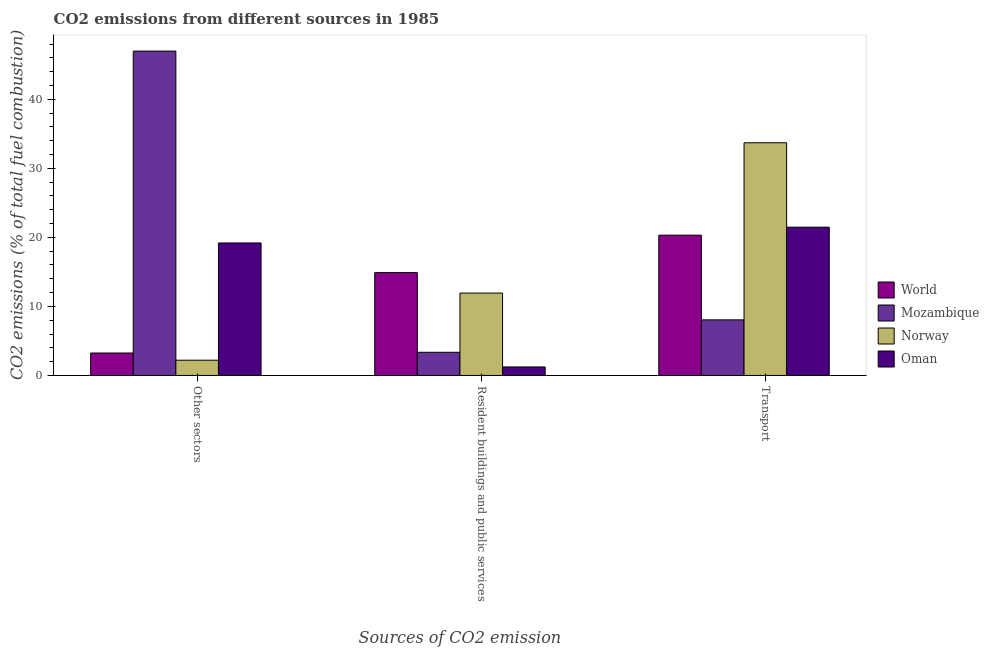How many bars are there on the 2nd tick from the right?
Ensure brevity in your answer.  4. What is the label of the 2nd group of bars from the left?
Make the answer very short. Resident buildings and public services. What is the percentage of co2 emissions from other sectors in Norway?
Make the answer very short. 2.21. Across all countries, what is the maximum percentage of co2 emissions from other sectors?
Your answer should be compact. 46.98. Across all countries, what is the minimum percentage of co2 emissions from transport?
Offer a terse response. 8.05. In which country was the percentage of co2 emissions from resident buildings and public services minimum?
Your answer should be very brief. Oman. What is the total percentage of co2 emissions from other sectors in the graph?
Your answer should be very brief. 71.63. What is the difference between the percentage of co2 emissions from other sectors in Mozambique and that in Oman?
Keep it short and to the point. 27.79. What is the difference between the percentage of co2 emissions from resident buildings and public services in Mozambique and the percentage of co2 emissions from transport in Oman?
Offer a terse response. -18.12. What is the average percentage of co2 emissions from transport per country?
Offer a very short reply. 20.89. What is the difference between the percentage of co2 emissions from other sectors and percentage of co2 emissions from transport in Mozambique?
Your answer should be very brief. 38.93. What is the ratio of the percentage of co2 emissions from other sectors in World to that in Mozambique?
Keep it short and to the point. 0.07. Is the percentage of co2 emissions from resident buildings and public services in World less than that in Mozambique?
Your response must be concise. No. What is the difference between the highest and the second highest percentage of co2 emissions from resident buildings and public services?
Ensure brevity in your answer.  2.96. What is the difference between the highest and the lowest percentage of co2 emissions from other sectors?
Provide a short and direct response. 44.77. In how many countries, is the percentage of co2 emissions from other sectors greater than the average percentage of co2 emissions from other sectors taken over all countries?
Offer a terse response. 2. Is the sum of the percentage of co2 emissions from other sectors in World and Mozambique greater than the maximum percentage of co2 emissions from transport across all countries?
Give a very brief answer. Yes. What does the 2nd bar from the left in Resident buildings and public services represents?
Make the answer very short. Mozambique. What does the 4th bar from the right in Other sectors represents?
Provide a short and direct response. World. Is it the case that in every country, the sum of the percentage of co2 emissions from other sectors and percentage of co2 emissions from resident buildings and public services is greater than the percentage of co2 emissions from transport?
Keep it short and to the point. No. How many bars are there?
Provide a succinct answer. 12. Are all the bars in the graph horizontal?
Offer a terse response. No. Does the graph contain grids?
Keep it short and to the point. No. Where does the legend appear in the graph?
Provide a succinct answer. Center right. How are the legend labels stacked?
Give a very brief answer. Vertical. What is the title of the graph?
Make the answer very short. CO2 emissions from different sources in 1985. Does "Upper middle income" appear as one of the legend labels in the graph?
Give a very brief answer. No. What is the label or title of the X-axis?
Provide a short and direct response. Sources of CO2 emission. What is the label or title of the Y-axis?
Your answer should be compact. CO2 emissions (% of total fuel combustion). What is the CO2 emissions (% of total fuel combustion) of World in Other sectors?
Make the answer very short. 3.25. What is the CO2 emissions (% of total fuel combustion) in Mozambique in Other sectors?
Make the answer very short. 46.98. What is the CO2 emissions (% of total fuel combustion) in Norway in Other sectors?
Offer a very short reply. 2.21. What is the CO2 emissions (% of total fuel combustion) of Oman in Other sectors?
Provide a succinct answer. 19.19. What is the CO2 emissions (% of total fuel combustion) of World in Resident buildings and public services?
Keep it short and to the point. 14.89. What is the CO2 emissions (% of total fuel combustion) in Mozambique in Resident buildings and public services?
Provide a succinct answer. 3.36. What is the CO2 emissions (% of total fuel combustion) in Norway in Resident buildings and public services?
Your response must be concise. 11.93. What is the CO2 emissions (% of total fuel combustion) of Oman in Resident buildings and public services?
Your response must be concise. 1.23. What is the CO2 emissions (% of total fuel combustion) of World in Transport?
Provide a short and direct response. 20.32. What is the CO2 emissions (% of total fuel combustion) in Mozambique in Transport?
Give a very brief answer. 8.05. What is the CO2 emissions (% of total fuel combustion) of Norway in Transport?
Offer a very short reply. 33.7. What is the CO2 emissions (% of total fuel combustion) in Oman in Transport?
Your response must be concise. 21.48. Across all Sources of CO2 emission, what is the maximum CO2 emissions (% of total fuel combustion) of World?
Ensure brevity in your answer.  20.32. Across all Sources of CO2 emission, what is the maximum CO2 emissions (% of total fuel combustion) in Mozambique?
Your answer should be very brief. 46.98. Across all Sources of CO2 emission, what is the maximum CO2 emissions (% of total fuel combustion) of Norway?
Your response must be concise. 33.7. Across all Sources of CO2 emission, what is the maximum CO2 emissions (% of total fuel combustion) of Oman?
Make the answer very short. 21.48. Across all Sources of CO2 emission, what is the minimum CO2 emissions (% of total fuel combustion) in World?
Keep it short and to the point. 3.25. Across all Sources of CO2 emission, what is the minimum CO2 emissions (% of total fuel combustion) of Mozambique?
Provide a short and direct response. 3.36. Across all Sources of CO2 emission, what is the minimum CO2 emissions (% of total fuel combustion) in Norway?
Keep it short and to the point. 2.21. Across all Sources of CO2 emission, what is the minimum CO2 emissions (% of total fuel combustion) of Oman?
Your response must be concise. 1.23. What is the total CO2 emissions (% of total fuel combustion) of World in the graph?
Your answer should be very brief. 38.46. What is the total CO2 emissions (% of total fuel combustion) of Mozambique in the graph?
Your response must be concise. 58.39. What is the total CO2 emissions (% of total fuel combustion) in Norway in the graph?
Your answer should be very brief. 47.85. What is the total CO2 emissions (% of total fuel combustion) of Oman in the graph?
Your answer should be very brief. 41.9. What is the difference between the CO2 emissions (% of total fuel combustion) in World in Other sectors and that in Resident buildings and public services?
Offer a very short reply. -11.64. What is the difference between the CO2 emissions (% of total fuel combustion) in Mozambique in Other sectors and that in Resident buildings and public services?
Keep it short and to the point. 43.62. What is the difference between the CO2 emissions (% of total fuel combustion) of Norway in Other sectors and that in Resident buildings and public services?
Offer a terse response. -9.72. What is the difference between the CO2 emissions (% of total fuel combustion) in Oman in Other sectors and that in Resident buildings and public services?
Provide a succinct answer. 17.96. What is the difference between the CO2 emissions (% of total fuel combustion) in World in Other sectors and that in Transport?
Your response must be concise. -17.07. What is the difference between the CO2 emissions (% of total fuel combustion) of Mozambique in Other sectors and that in Transport?
Offer a very short reply. 38.93. What is the difference between the CO2 emissions (% of total fuel combustion) in Norway in Other sectors and that in Transport?
Offer a very short reply. -31.49. What is the difference between the CO2 emissions (% of total fuel combustion) of Oman in Other sectors and that in Transport?
Your answer should be very brief. -2.29. What is the difference between the CO2 emissions (% of total fuel combustion) of World in Resident buildings and public services and that in Transport?
Offer a very short reply. -5.42. What is the difference between the CO2 emissions (% of total fuel combustion) of Mozambique in Resident buildings and public services and that in Transport?
Offer a terse response. -4.7. What is the difference between the CO2 emissions (% of total fuel combustion) in Norway in Resident buildings and public services and that in Transport?
Give a very brief answer. -21.77. What is the difference between the CO2 emissions (% of total fuel combustion) in Oman in Resident buildings and public services and that in Transport?
Provide a short and direct response. -20.25. What is the difference between the CO2 emissions (% of total fuel combustion) of World in Other sectors and the CO2 emissions (% of total fuel combustion) of Mozambique in Resident buildings and public services?
Ensure brevity in your answer.  -0.1. What is the difference between the CO2 emissions (% of total fuel combustion) of World in Other sectors and the CO2 emissions (% of total fuel combustion) of Norway in Resident buildings and public services?
Your answer should be compact. -8.68. What is the difference between the CO2 emissions (% of total fuel combustion) in World in Other sectors and the CO2 emissions (% of total fuel combustion) in Oman in Resident buildings and public services?
Your answer should be compact. 2.02. What is the difference between the CO2 emissions (% of total fuel combustion) in Mozambique in Other sectors and the CO2 emissions (% of total fuel combustion) in Norway in Resident buildings and public services?
Give a very brief answer. 35.05. What is the difference between the CO2 emissions (% of total fuel combustion) of Mozambique in Other sectors and the CO2 emissions (% of total fuel combustion) of Oman in Resident buildings and public services?
Offer a very short reply. 45.75. What is the difference between the CO2 emissions (% of total fuel combustion) in Norway in Other sectors and the CO2 emissions (% of total fuel combustion) in Oman in Resident buildings and public services?
Offer a very short reply. 0.98. What is the difference between the CO2 emissions (% of total fuel combustion) in World in Other sectors and the CO2 emissions (% of total fuel combustion) in Mozambique in Transport?
Ensure brevity in your answer.  -4.8. What is the difference between the CO2 emissions (% of total fuel combustion) in World in Other sectors and the CO2 emissions (% of total fuel combustion) in Norway in Transport?
Keep it short and to the point. -30.45. What is the difference between the CO2 emissions (% of total fuel combustion) in World in Other sectors and the CO2 emissions (% of total fuel combustion) in Oman in Transport?
Make the answer very short. -18.23. What is the difference between the CO2 emissions (% of total fuel combustion) in Mozambique in Other sectors and the CO2 emissions (% of total fuel combustion) in Norway in Transport?
Provide a succinct answer. 13.28. What is the difference between the CO2 emissions (% of total fuel combustion) of Mozambique in Other sectors and the CO2 emissions (% of total fuel combustion) of Oman in Transport?
Your response must be concise. 25.5. What is the difference between the CO2 emissions (% of total fuel combustion) in Norway in Other sectors and the CO2 emissions (% of total fuel combustion) in Oman in Transport?
Make the answer very short. -19.27. What is the difference between the CO2 emissions (% of total fuel combustion) in World in Resident buildings and public services and the CO2 emissions (% of total fuel combustion) in Mozambique in Transport?
Your answer should be very brief. 6.84. What is the difference between the CO2 emissions (% of total fuel combustion) in World in Resident buildings and public services and the CO2 emissions (% of total fuel combustion) in Norway in Transport?
Offer a terse response. -18.81. What is the difference between the CO2 emissions (% of total fuel combustion) of World in Resident buildings and public services and the CO2 emissions (% of total fuel combustion) of Oman in Transport?
Your response must be concise. -6.58. What is the difference between the CO2 emissions (% of total fuel combustion) in Mozambique in Resident buildings and public services and the CO2 emissions (% of total fuel combustion) in Norway in Transport?
Provide a succinct answer. -30.35. What is the difference between the CO2 emissions (% of total fuel combustion) of Mozambique in Resident buildings and public services and the CO2 emissions (% of total fuel combustion) of Oman in Transport?
Give a very brief answer. -18.12. What is the difference between the CO2 emissions (% of total fuel combustion) in Norway in Resident buildings and public services and the CO2 emissions (% of total fuel combustion) in Oman in Transport?
Make the answer very short. -9.55. What is the average CO2 emissions (% of total fuel combustion) of World per Sources of CO2 emission?
Provide a short and direct response. 12.82. What is the average CO2 emissions (% of total fuel combustion) in Mozambique per Sources of CO2 emission?
Ensure brevity in your answer.  19.46. What is the average CO2 emissions (% of total fuel combustion) in Norway per Sources of CO2 emission?
Your response must be concise. 15.95. What is the average CO2 emissions (% of total fuel combustion) of Oman per Sources of CO2 emission?
Provide a succinct answer. 13.97. What is the difference between the CO2 emissions (% of total fuel combustion) of World and CO2 emissions (% of total fuel combustion) of Mozambique in Other sectors?
Your answer should be very brief. -43.73. What is the difference between the CO2 emissions (% of total fuel combustion) of World and CO2 emissions (% of total fuel combustion) of Norway in Other sectors?
Ensure brevity in your answer.  1.04. What is the difference between the CO2 emissions (% of total fuel combustion) in World and CO2 emissions (% of total fuel combustion) in Oman in Other sectors?
Your answer should be compact. -15.94. What is the difference between the CO2 emissions (% of total fuel combustion) in Mozambique and CO2 emissions (% of total fuel combustion) in Norway in Other sectors?
Provide a short and direct response. 44.77. What is the difference between the CO2 emissions (% of total fuel combustion) in Mozambique and CO2 emissions (% of total fuel combustion) in Oman in Other sectors?
Offer a very short reply. 27.79. What is the difference between the CO2 emissions (% of total fuel combustion) in Norway and CO2 emissions (% of total fuel combustion) in Oman in Other sectors?
Your answer should be compact. -16.98. What is the difference between the CO2 emissions (% of total fuel combustion) in World and CO2 emissions (% of total fuel combustion) in Mozambique in Resident buildings and public services?
Your answer should be compact. 11.54. What is the difference between the CO2 emissions (% of total fuel combustion) of World and CO2 emissions (% of total fuel combustion) of Norway in Resident buildings and public services?
Offer a very short reply. 2.96. What is the difference between the CO2 emissions (% of total fuel combustion) in World and CO2 emissions (% of total fuel combustion) in Oman in Resident buildings and public services?
Provide a succinct answer. 13.66. What is the difference between the CO2 emissions (% of total fuel combustion) of Mozambique and CO2 emissions (% of total fuel combustion) of Norway in Resident buildings and public services?
Offer a very short reply. -8.58. What is the difference between the CO2 emissions (% of total fuel combustion) in Mozambique and CO2 emissions (% of total fuel combustion) in Oman in Resident buildings and public services?
Your answer should be compact. 2.12. What is the difference between the CO2 emissions (% of total fuel combustion) in Norway and CO2 emissions (% of total fuel combustion) in Oman in Resident buildings and public services?
Your answer should be very brief. 10.7. What is the difference between the CO2 emissions (% of total fuel combustion) of World and CO2 emissions (% of total fuel combustion) of Mozambique in Transport?
Provide a short and direct response. 12.26. What is the difference between the CO2 emissions (% of total fuel combustion) of World and CO2 emissions (% of total fuel combustion) of Norway in Transport?
Your response must be concise. -13.38. What is the difference between the CO2 emissions (% of total fuel combustion) of World and CO2 emissions (% of total fuel combustion) of Oman in Transport?
Provide a short and direct response. -1.16. What is the difference between the CO2 emissions (% of total fuel combustion) of Mozambique and CO2 emissions (% of total fuel combustion) of Norway in Transport?
Provide a succinct answer. -25.65. What is the difference between the CO2 emissions (% of total fuel combustion) of Mozambique and CO2 emissions (% of total fuel combustion) of Oman in Transport?
Provide a succinct answer. -13.43. What is the difference between the CO2 emissions (% of total fuel combustion) of Norway and CO2 emissions (% of total fuel combustion) of Oman in Transport?
Make the answer very short. 12.22. What is the ratio of the CO2 emissions (% of total fuel combustion) in World in Other sectors to that in Resident buildings and public services?
Offer a very short reply. 0.22. What is the ratio of the CO2 emissions (% of total fuel combustion) in Norway in Other sectors to that in Resident buildings and public services?
Keep it short and to the point. 0.19. What is the ratio of the CO2 emissions (% of total fuel combustion) of Oman in Other sectors to that in Resident buildings and public services?
Your response must be concise. 15.57. What is the ratio of the CO2 emissions (% of total fuel combustion) in World in Other sectors to that in Transport?
Your answer should be compact. 0.16. What is the ratio of the CO2 emissions (% of total fuel combustion) in Mozambique in Other sectors to that in Transport?
Your response must be concise. 5.83. What is the ratio of the CO2 emissions (% of total fuel combustion) of Norway in Other sectors to that in Transport?
Provide a succinct answer. 0.07. What is the ratio of the CO2 emissions (% of total fuel combustion) of Oman in Other sectors to that in Transport?
Ensure brevity in your answer.  0.89. What is the ratio of the CO2 emissions (% of total fuel combustion) in World in Resident buildings and public services to that in Transport?
Make the answer very short. 0.73. What is the ratio of the CO2 emissions (% of total fuel combustion) of Mozambique in Resident buildings and public services to that in Transport?
Offer a terse response. 0.42. What is the ratio of the CO2 emissions (% of total fuel combustion) of Norway in Resident buildings and public services to that in Transport?
Your answer should be compact. 0.35. What is the ratio of the CO2 emissions (% of total fuel combustion) in Oman in Resident buildings and public services to that in Transport?
Your answer should be very brief. 0.06. What is the difference between the highest and the second highest CO2 emissions (% of total fuel combustion) in World?
Offer a very short reply. 5.42. What is the difference between the highest and the second highest CO2 emissions (% of total fuel combustion) of Mozambique?
Ensure brevity in your answer.  38.93. What is the difference between the highest and the second highest CO2 emissions (% of total fuel combustion) in Norway?
Your answer should be very brief. 21.77. What is the difference between the highest and the second highest CO2 emissions (% of total fuel combustion) of Oman?
Give a very brief answer. 2.29. What is the difference between the highest and the lowest CO2 emissions (% of total fuel combustion) in World?
Make the answer very short. 17.07. What is the difference between the highest and the lowest CO2 emissions (% of total fuel combustion) in Mozambique?
Make the answer very short. 43.62. What is the difference between the highest and the lowest CO2 emissions (% of total fuel combustion) in Norway?
Ensure brevity in your answer.  31.49. What is the difference between the highest and the lowest CO2 emissions (% of total fuel combustion) in Oman?
Make the answer very short. 20.25. 